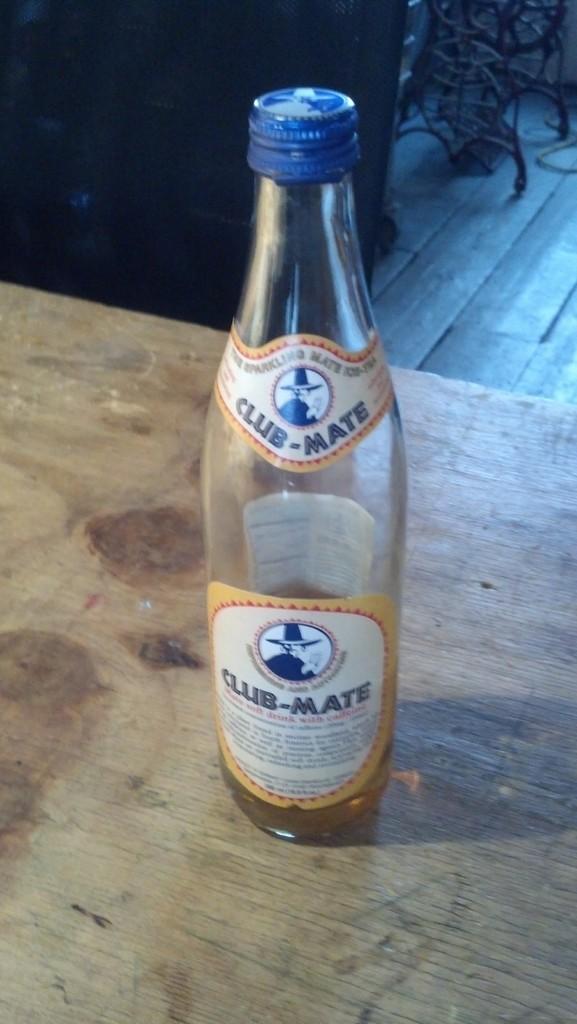What is the name of the drink?
Keep it short and to the point. Club-mate. 